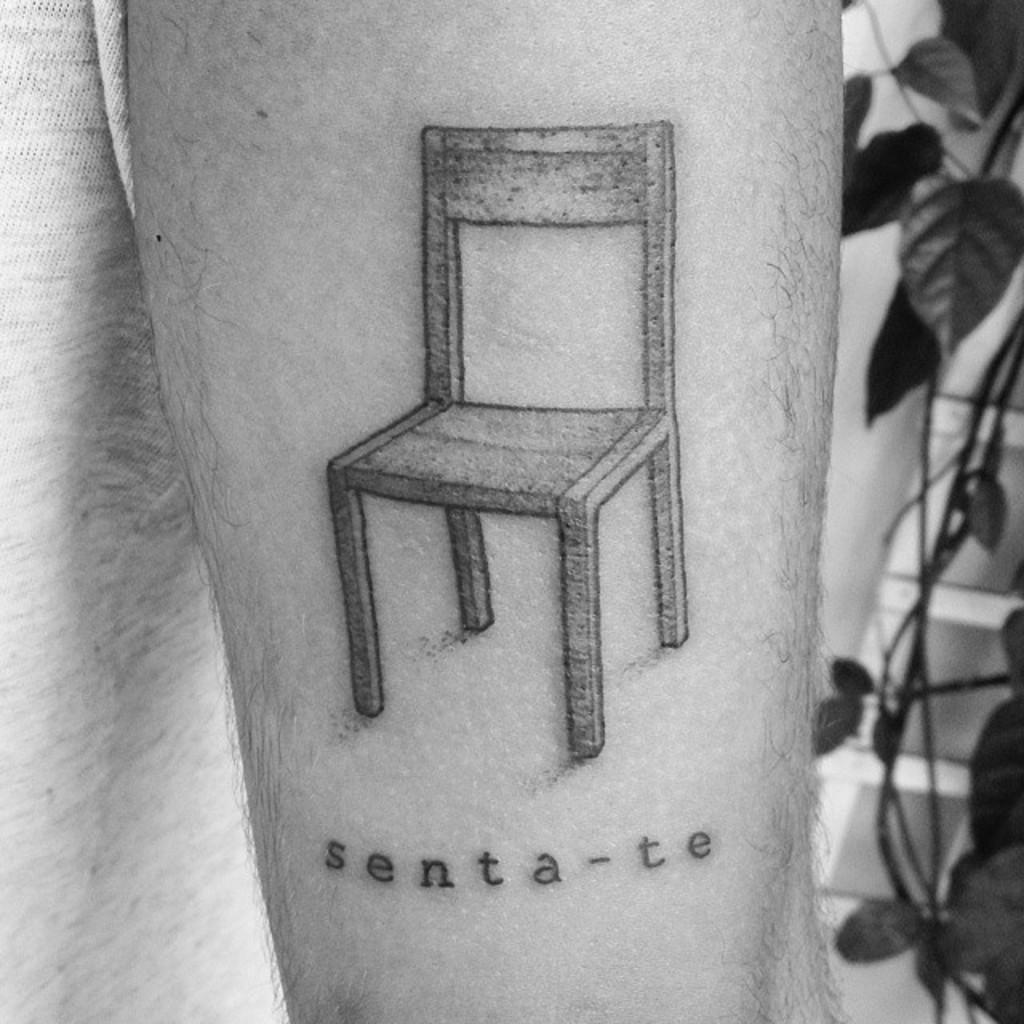What can be seen on a human body in the image? There is a tattoo on a human body in the image. What is located on the left side of the image? There is a cloth on the left side of the image. What type of plant is visible on the right side of the image? There is a plant with leaves and stems on the right side of the image. What type of straw is being used for learning in the image? There is no straw or learning activity present in the image. 